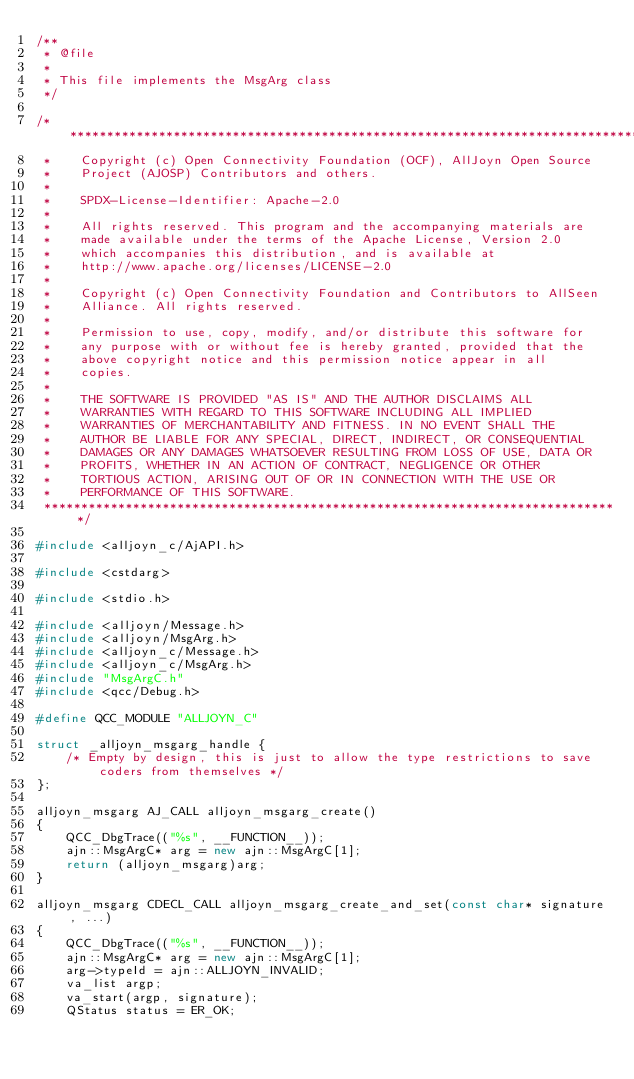<code> <loc_0><loc_0><loc_500><loc_500><_C++_>/**
 * @file
 *
 * This file implements the MsgArg class
 */

/******************************************************************************
 *    Copyright (c) Open Connectivity Foundation (OCF), AllJoyn Open Source
 *    Project (AJOSP) Contributors and others.
 *
 *    SPDX-License-Identifier: Apache-2.0
 *
 *    All rights reserved. This program and the accompanying materials are
 *    made available under the terms of the Apache License, Version 2.0
 *    which accompanies this distribution, and is available at
 *    http://www.apache.org/licenses/LICENSE-2.0
 *
 *    Copyright (c) Open Connectivity Foundation and Contributors to AllSeen
 *    Alliance. All rights reserved.
 *
 *    Permission to use, copy, modify, and/or distribute this software for
 *    any purpose with or without fee is hereby granted, provided that the
 *    above copyright notice and this permission notice appear in all
 *    copies.
 *
 *    THE SOFTWARE IS PROVIDED "AS IS" AND THE AUTHOR DISCLAIMS ALL
 *    WARRANTIES WITH REGARD TO THIS SOFTWARE INCLUDING ALL IMPLIED
 *    WARRANTIES OF MERCHANTABILITY AND FITNESS. IN NO EVENT SHALL THE
 *    AUTHOR BE LIABLE FOR ANY SPECIAL, DIRECT, INDIRECT, OR CONSEQUENTIAL
 *    DAMAGES OR ANY DAMAGES WHATSOEVER RESULTING FROM LOSS OF USE, DATA OR
 *    PROFITS, WHETHER IN AN ACTION OF CONTRACT, NEGLIGENCE OR OTHER
 *    TORTIOUS ACTION, ARISING OUT OF OR IN CONNECTION WITH THE USE OR
 *    PERFORMANCE OF THIS SOFTWARE.
 ******************************************************************************/

#include <alljoyn_c/AjAPI.h>

#include <cstdarg>

#include <stdio.h>

#include <alljoyn/Message.h>
#include <alljoyn/MsgArg.h>
#include <alljoyn_c/Message.h>
#include <alljoyn_c/MsgArg.h>
#include "MsgArgC.h"
#include <qcc/Debug.h>

#define QCC_MODULE "ALLJOYN_C"

struct _alljoyn_msgarg_handle {
    /* Empty by design, this is just to allow the type restrictions to save coders from themselves */
};

alljoyn_msgarg AJ_CALL alljoyn_msgarg_create()
{
    QCC_DbgTrace(("%s", __FUNCTION__));
    ajn::MsgArgC* arg = new ajn::MsgArgC[1];
    return (alljoyn_msgarg)arg;
}

alljoyn_msgarg CDECL_CALL alljoyn_msgarg_create_and_set(const char* signature, ...)
{
    QCC_DbgTrace(("%s", __FUNCTION__));
    ajn::MsgArgC* arg = new ajn::MsgArgC[1];
    arg->typeId = ajn::ALLJOYN_INVALID;
    va_list argp;
    va_start(argp, signature);
    QStatus status = ER_OK;
</code> 